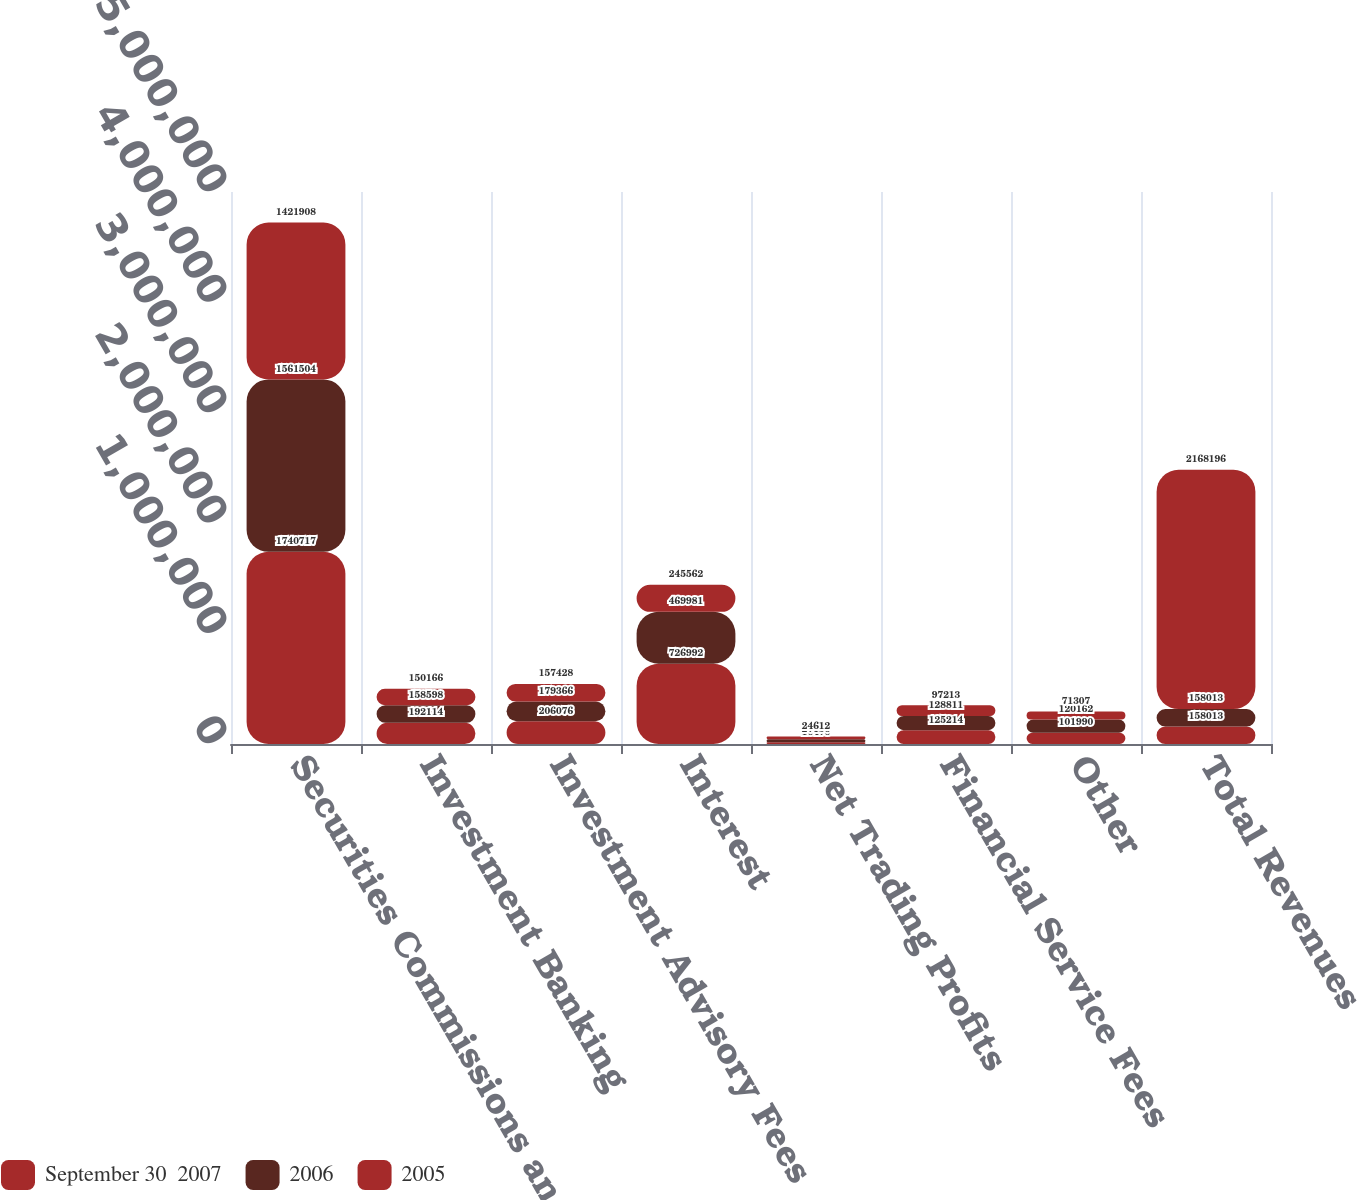<chart> <loc_0><loc_0><loc_500><loc_500><stacked_bar_chart><ecel><fcel>Securities Commissions and<fcel>Investment Banking<fcel>Investment Advisory Fees<fcel>Interest<fcel>Net Trading Profits<fcel>Financial Service Fees<fcel>Other<fcel>Total Revenues<nl><fcel>September 30  2007<fcel>1.74072e+06<fcel>192114<fcel>206076<fcel>726992<fcel>16476<fcel>125214<fcel>101990<fcel>158013<nl><fcel>2006<fcel>1.5615e+06<fcel>158598<fcel>179366<fcel>469981<fcel>27156<fcel>128811<fcel>120162<fcel>158013<nl><fcel>2005<fcel>1.42191e+06<fcel>150166<fcel>157428<fcel>245562<fcel>24612<fcel>97213<fcel>71307<fcel>2.1682e+06<nl></chart> 